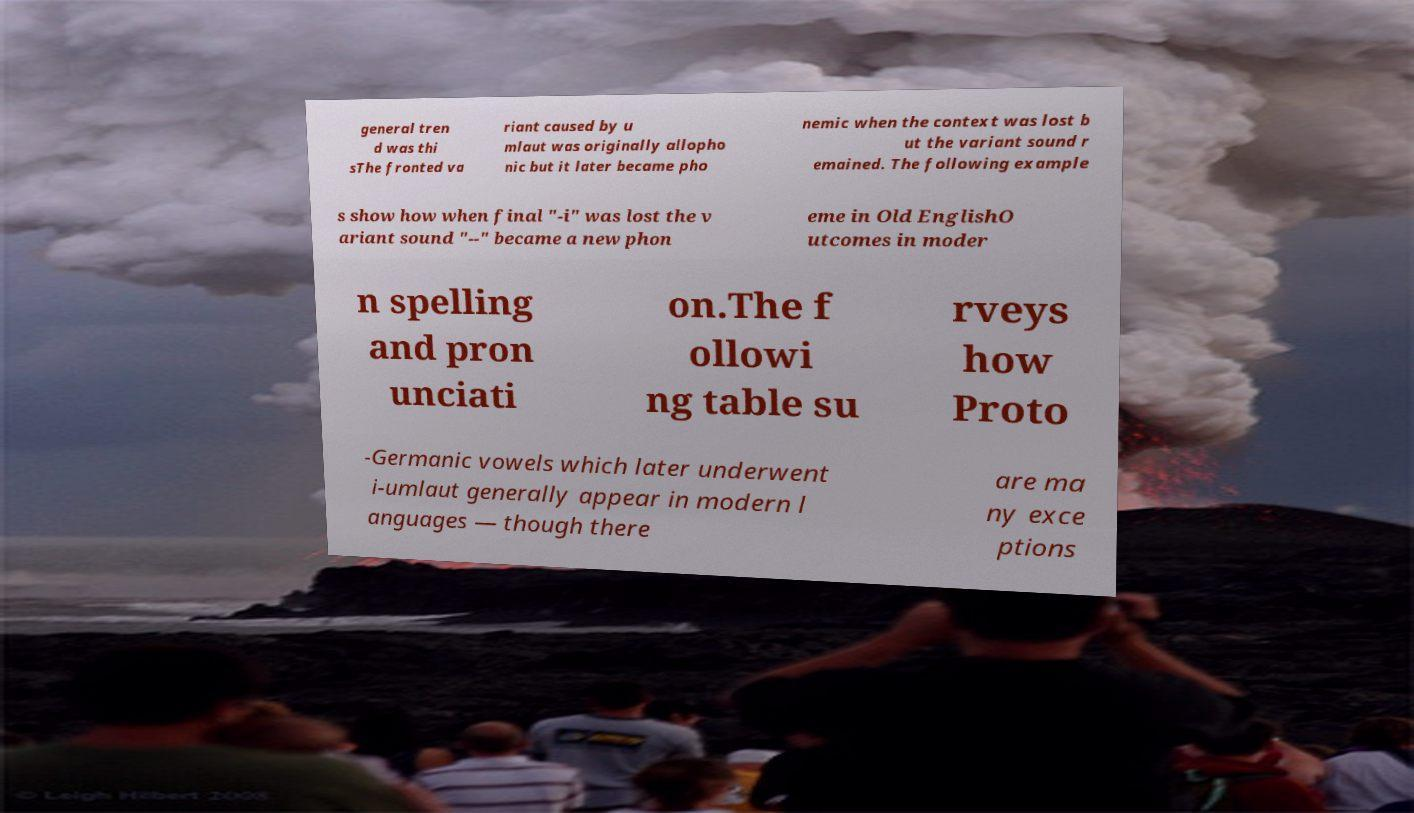What messages or text are displayed in this image? I need them in a readable, typed format. general tren d was thi sThe fronted va riant caused by u mlaut was originally allopho nic but it later became pho nemic when the context was lost b ut the variant sound r emained. The following example s show how when final "-i" was lost the v ariant sound "--" became a new phon eme in Old EnglishO utcomes in moder n spelling and pron unciati on.The f ollowi ng table su rveys how Proto -Germanic vowels which later underwent i-umlaut generally appear in modern l anguages — though there are ma ny exce ptions 